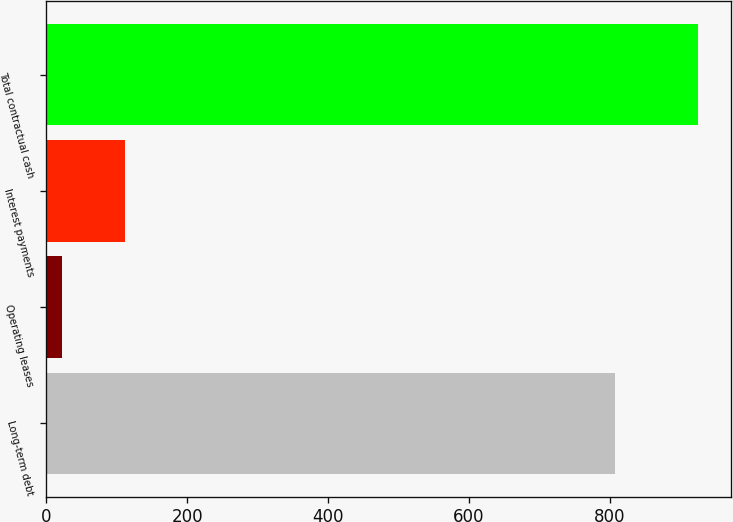<chart> <loc_0><loc_0><loc_500><loc_500><bar_chart><fcel>Long-term debt<fcel>Operating leases<fcel>Interest payments<fcel>Total contractual cash<nl><fcel>808.1<fcel>21.9<fcel>112.27<fcel>925.6<nl></chart> 